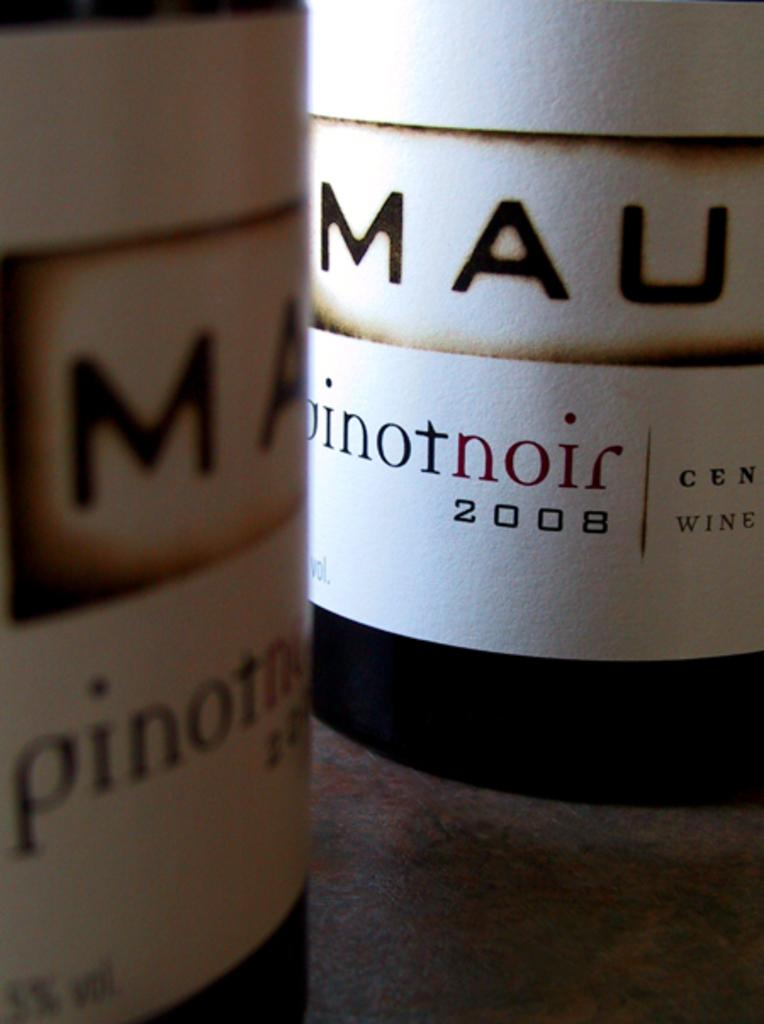<image>
Describe the image concisely. A bottle of Mau pinot noir is from the year 2008. 